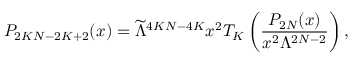<formula> <loc_0><loc_0><loc_500><loc_500>P _ { 2 K N - 2 K + 2 } ( x ) = \widetilde { \Lambda } ^ { 4 K N - 4 K } x ^ { 2 } T _ { K } \left ( \frac { P _ { 2 N } ( x ) } { x ^ { 2 } \Lambda ^ { 2 N - 2 } } \right ) ,</formula> 